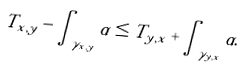<formula> <loc_0><loc_0><loc_500><loc_500>T _ { x , y } - \int _ { \gamma _ { x , y } } \alpha \leq T _ { y , x } + \int _ { \gamma _ { y , x } } \alpha .</formula> 